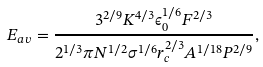<formula> <loc_0><loc_0><loc_500><loc_500>E _ { a v } = \frac { 3 ^ { 2 / 9 } K ^ { 4 / 3 } \epsilon _ { 0 } ^ { 1 / 6 } F ^ { 2 / 3 } } { 2 ^ { 1 / 3 } \pi N ^ { 1 / 2 } \sigma ^ { 1 / 6 } r _ { c } ^ { 2 / 3 } A ^ { 1 / 1 8 } P ^ { 2 / 9 } } ,</formula> 